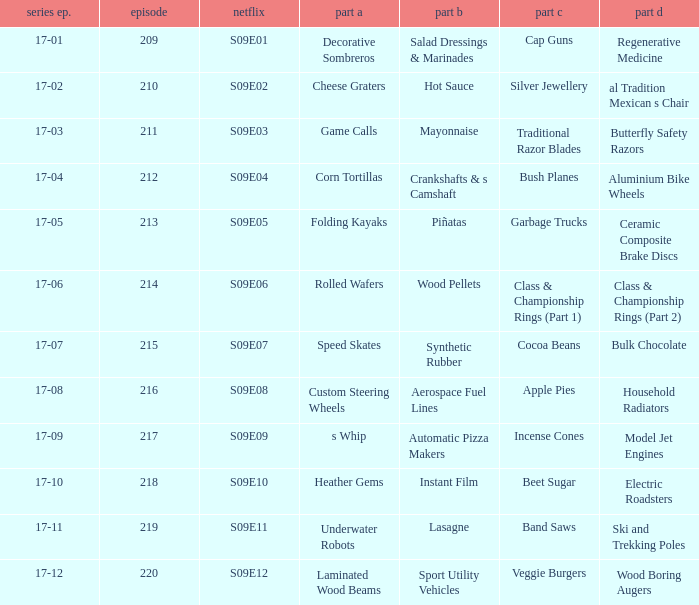Are rolled wafers in many episodes 17-06. 